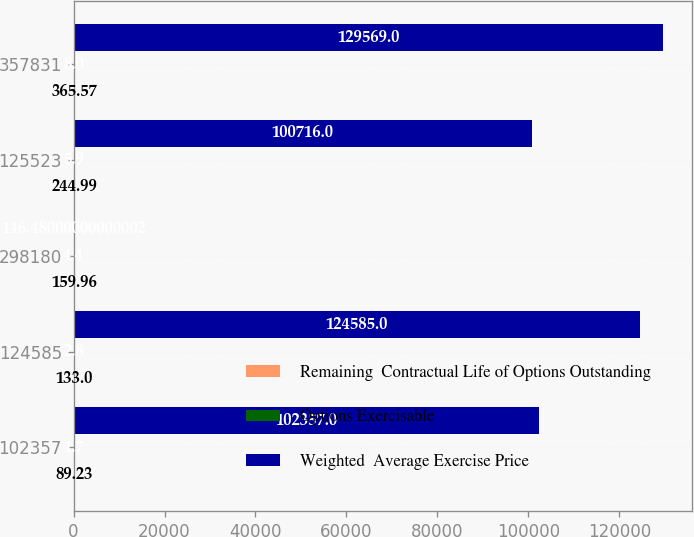Convert chart to OTSL. <chart><loc_0><loc_0><loc_500><loc_500><stacked_bar_chart><ecel><fcel>102357<fcel>124585<fcel>298180<fcel>125523<fcel>357831<nl><fcel>Remaining  Contractual Life of Options Outstanding<fcel>89.23<fcel>133<fcel>159.96<fcel>244.99<fcel>365.57<nl><fcel>Options Exercisable<fcel>1.7<fcel>2.8<fcel>4.4<fcel>5.9<fcel>8<nl><fcel>Weighted  Average Exercise Price<fcel>102357<fcel>124585<fcel>146.48<fcel>100716<fcel>129569<nl></chart> 